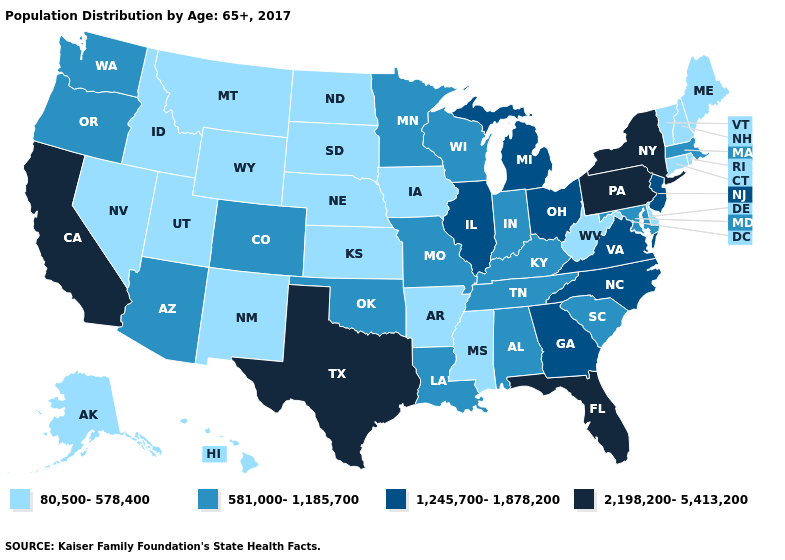Name the states that have a value in the range 581,000-1,185,700?
Quick response, please. Alabama, Arizona, Colorado, Indiana, Kentucky, Louisiana, Maryland, Massachusetts, Minnesota, Missouri, Oklahoma, Oregon, South Carolina, Tennessee, Washington, Wisconsin. What is the value of South Dakota?
Keep it brief. 80,500-578,400. Is the legend a continuous bar?
Give a very brief answer. No. Among the states that border Louisiana , does Arkansas have the lowest value?
Be succinct. Yes. Does Wyoming have the highest value in the USA?
Quick response, please. No. Among the states that border North Dakota , does Minnesota have the highest value?
Short answer required. Yes. Which states hav the highest value in the Northeast?
Give a very brief answer. New York, Pennsylvania. Does Kentucky have the highest value in the South?
Keep it brief. No. Does Idaho have a lower value than Georgia?
Quick response, please. Yes. What is the value of North Dakota?
Short answer required. 80,500-578,400. Name the states that have a value in the range 581,000-1,185,700?
Quick response, please. Alabama, Arizona, Colorado, Indiana, Kentucky, Louisiana, Maryland, Massachusetts, Minnesota, Missouri, Oklahoma, Oregon, South Carolina, Tennessee, Washington, Wisconsin. Does Colorado have the lowest value in the USA?
Quick response, please. No. What is the highest value in states that border Massachusetts?
Concise answer only. 2,198,200-5,413,200. Does the first symbol in the legend represent the smallest category?
Quick response, please. Yes. What is the value of Illinois?
Answer briefly. 1,245,700-1,878,200. 